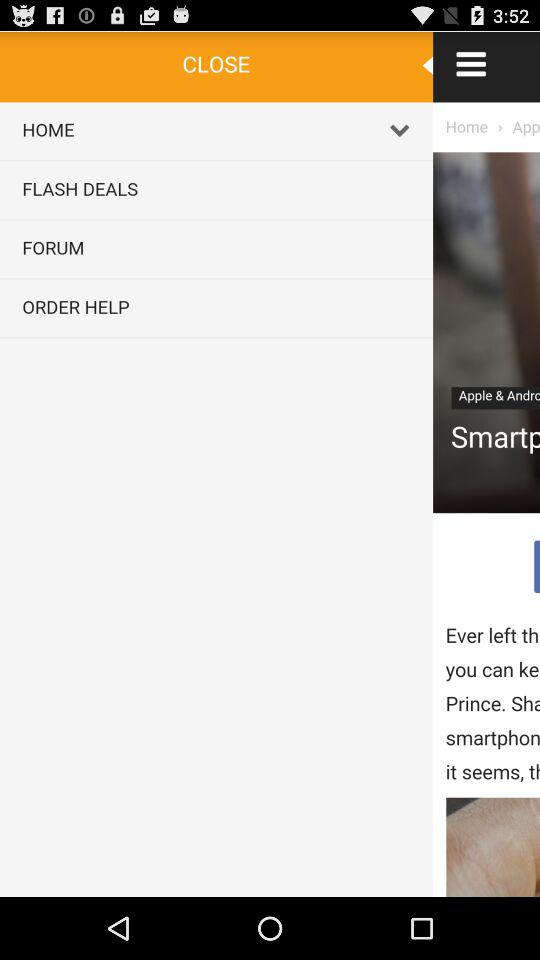What is the price of the "MantisTek® WR300 300Mbps dual 5dBi Wireless WiFi Repeat..."? The price is US$17.99. 